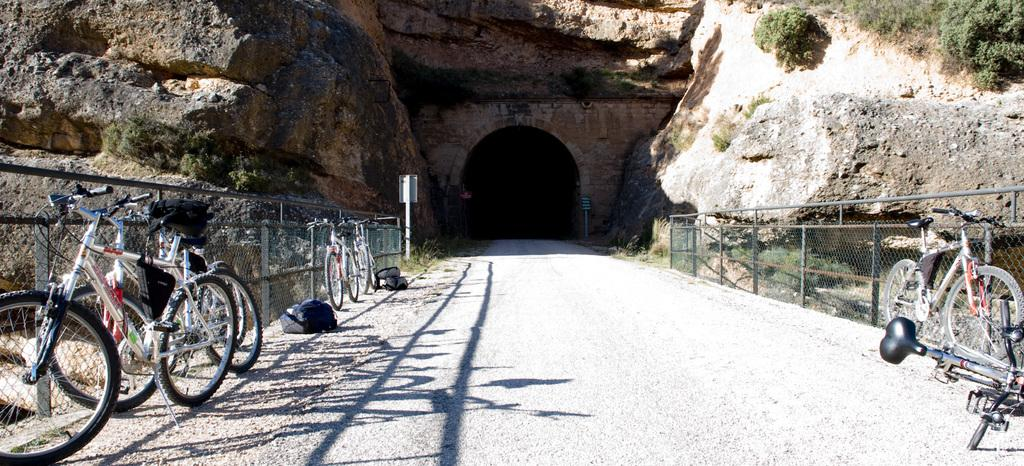What is the main feature of the hill in the image? There is a tunnel in the hill in the image. What type of vegetation can be seen in the image? There are trees in the image. What structures are present in the image? There are fences in the image. What are the people using to travel in the image? There are bicycles on the road in the image. What items are visible in the image that might be used for carrying belongings? There are bags in the image. Can you hear the ocean in the image? There is no reference to the ocean or any sounds in the image, so it's not possible to determine if the ocean can be heard. 